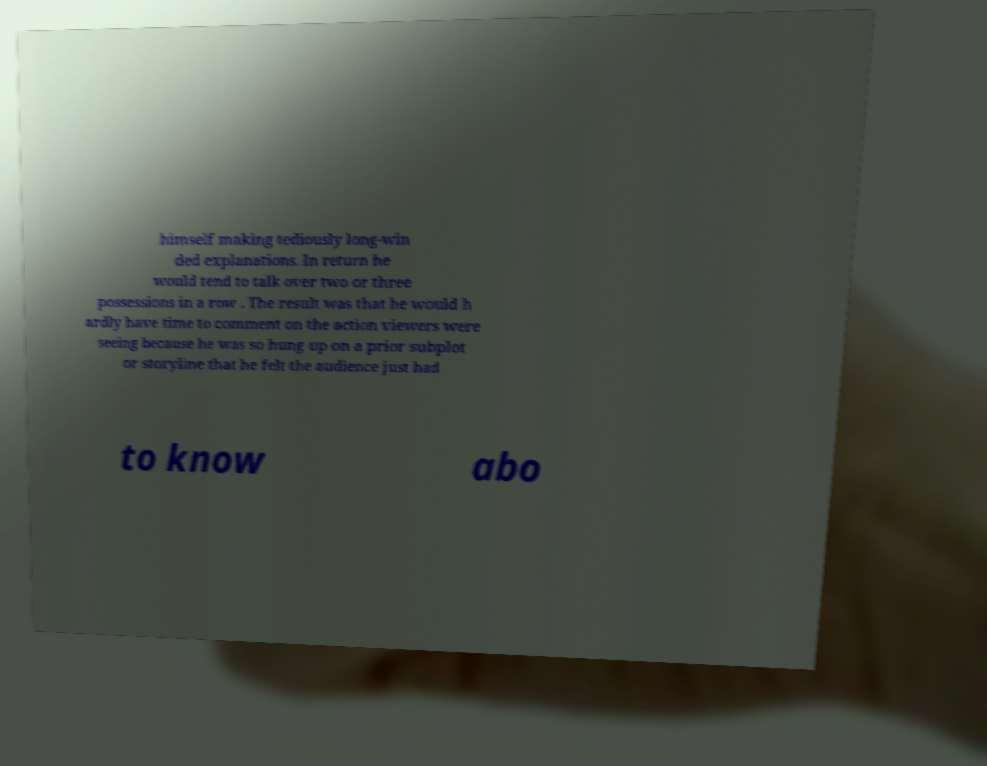Could you extract and type out the text from this image? himself making tediously long-win ded explanations. In return he would tend to talk over two or three possessions in a row . The result was that he would h ardly have time to comment on the action viewers were seeing because he was so hung up on a prior subplot or storyline that he felt the audience just had to know abo 